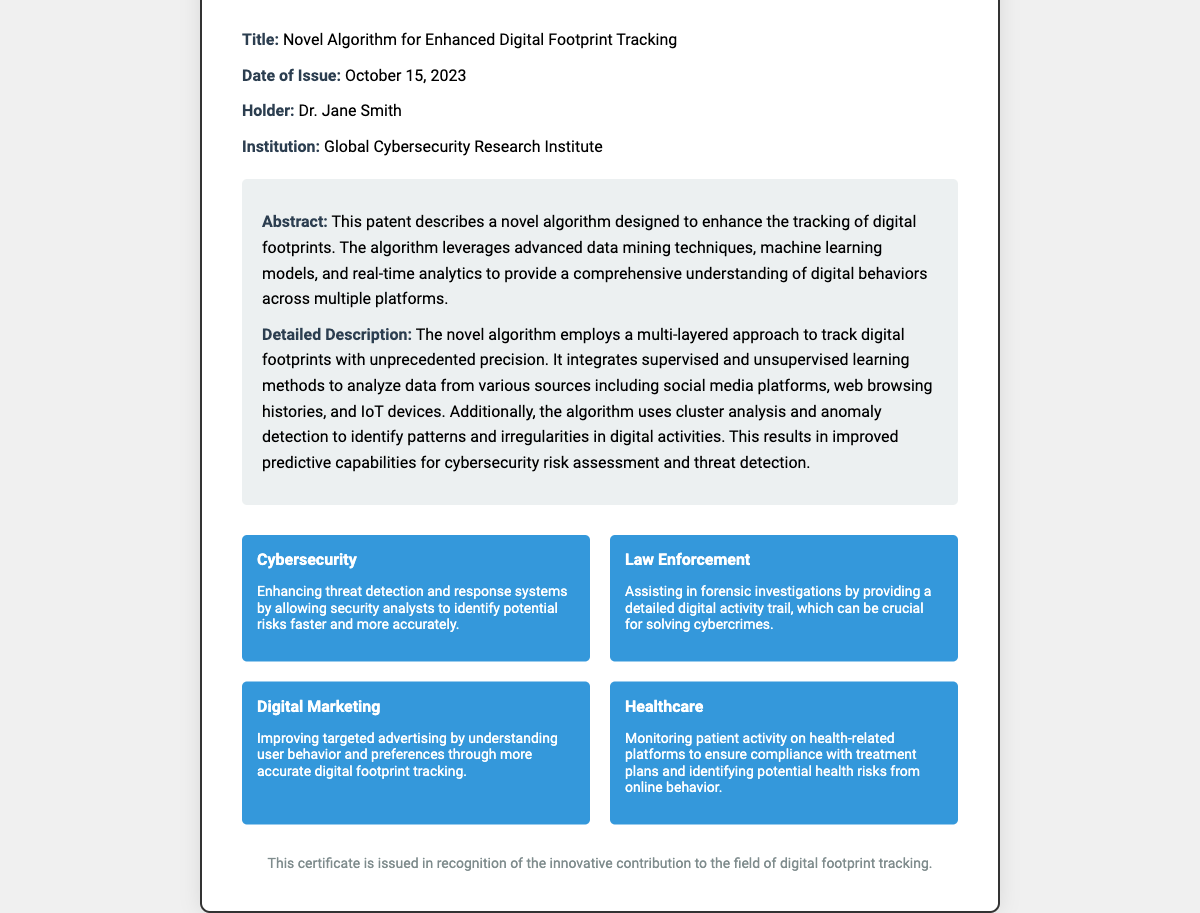What is the title of the patent? The title is provided in the document under a specific section labeled "Title".
Answer: Novel Algorithm for Enhanced Digital Footprint Tracking Who is the holder of the patent? The holder is mentioned in the document as part of the "Holder" information section.
Answer: Dr. Jane Smith What is the patent number? The patent number is indicated prominently at the top of the certificate under "Patent No".
Answer: US12345678B2 What institution is associated with the patent? The associated institution is listed in the document under the "Institution" section.
Answer: Global Cybersecurity Research Institute When was the patent issued? The date of issue is provided in the document specifically under the "Date of Issue" section.
Answer: October 15, 2023 What advanced techniques does the algorithm leverage? The document mentions that the algorithm uses advanced techniques which are detailed in the “Detailed Description” section.
Answer: Data mining techniques, machine learning models, and real-time analytics How does the algorithm improve predictive capabilities? The document describes how the algorithm uses certain methods to enhance predictive capabilities, which connects multiple aspects mentioned.
Answer: By integrating supervised and unsupervised learning methods What application is related to digital marketing? The document lists various applications and specifies one related to digital marketing.
Answer: Improving targeted advertising Which application can benefit law enforcement? The document outlines applications and includes one that supports law enforcement specifically.
Answer: Assisting in forensic investigations 